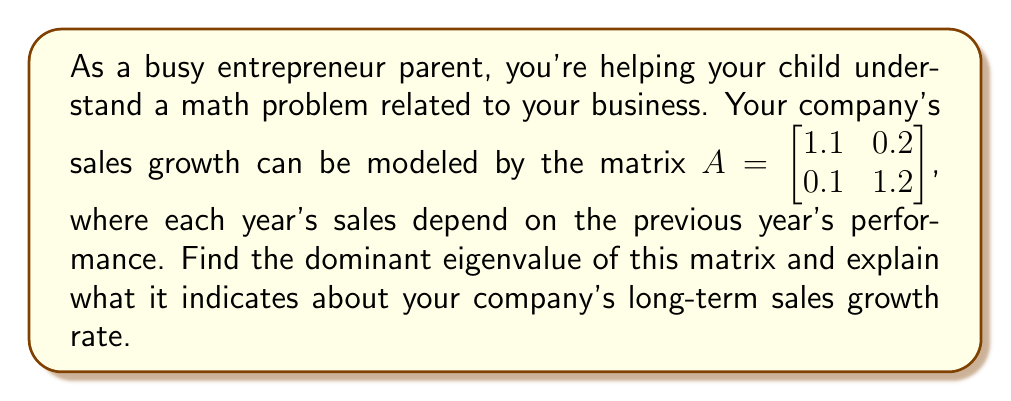Provide a solution to this math problem. Let's approach this step-by-step:

1) To find the eigenvalues, we need to solve the characteristic equation:
   $det(A - \lambda I) = 0$

2) Expanding this:
   $\begin{vmatrix} 1.1 - \lambda & 0.2 \\ 0.1 & 1.2 - \lambda \end{vmatrix} = 0$

3) This gives us:
   $(1.1 - \lambda)(1.2 - \lambda) - 0.02 = 0$

4) Simplifying:
   $\lambda^2 - 2.3\lambda + 1.3 = 0$

5) Using the quadratic formula, $\lambda = \frac{-b \pm \sqrt{b^2 - 4ac}}{2a}$, we get:
   $\lambda_1 = \frac{2.3 + \sqrt{0.13}}{2} \approx 1.28$
   $\lambda_2 = \frac{2.3 - \sqrt{0.13}}{2} \approx 1.02$

6) The dominant eigenvalue is the larger one: $\lambda_1 \approx 1.28$

7) In terms of sales growth, the dominant eigenvalue represents the long-term growth factor. A value greater than 1 indicates growth.

8) To convert this to a percentage, we subtract 1 and multiply by 100:
   $(1.28 - 1) * 100 = 28\%$

This means the company's sales are projected to grow by approximately 28% year-over-year in the long term.
Answer: 28% 